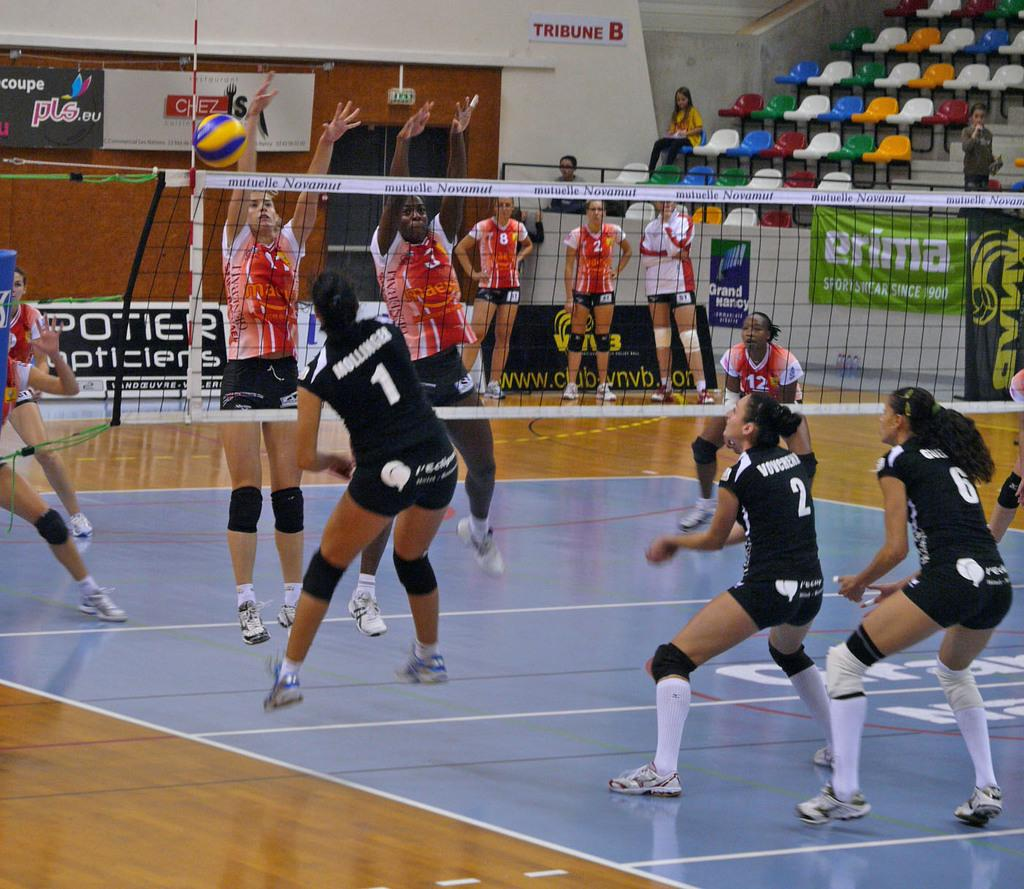<image>
Provide a brief description of the given image. The girl in black by the net is wearing number 1 